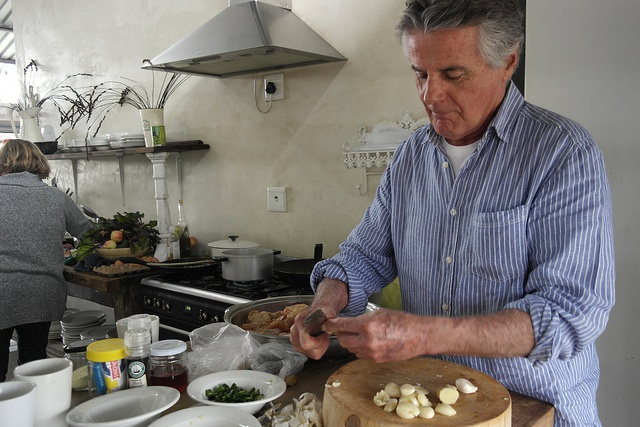Describe the objects in this image and their specific colors. I can see people in lightgray, gray, darkgray, and brown tones, dining table in lightgray, darkgray, gray, maroon, and black tones, people in lightgray, gray, and black tones, oven in lightgray, black, darkgray, and gray tones, and potted plant in lightgray, darkgray, and gray tones in this image. 